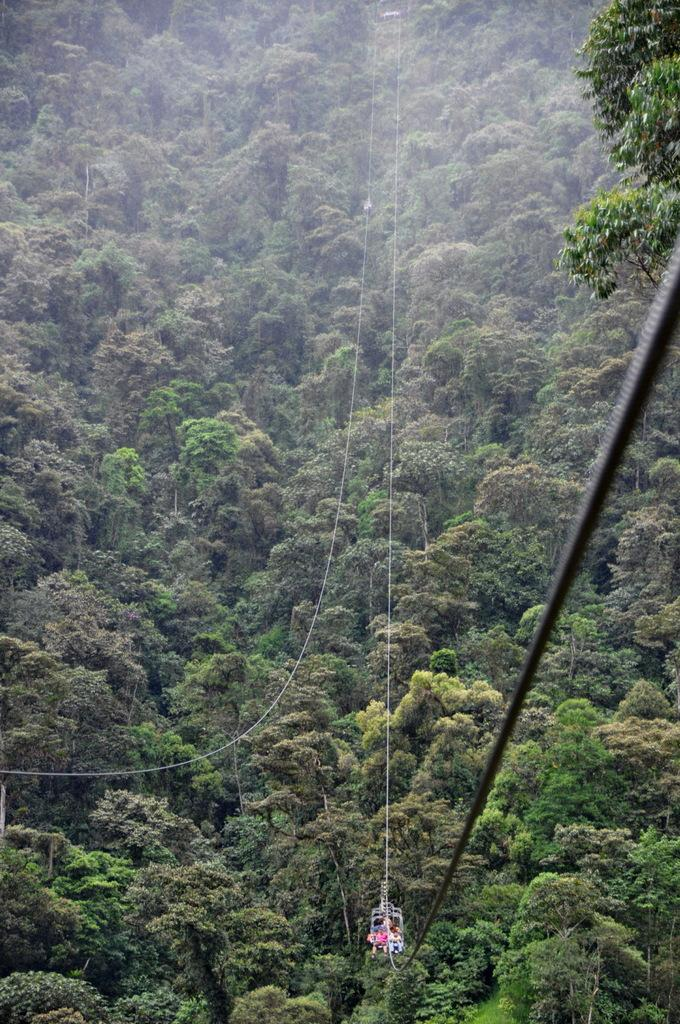What type of view is shown in the image? The image is an aerial view. What can be seen in the center of the image? There is a ropeway in the center of the image. What is visible in the background of the image? There are trees visible in the background of the image. How many guns are visible in the image? There are no guns present in the image. What level of experience is required to use the ropeway in the image? The image does not provide information about the level of experience required to use the ropeway. 